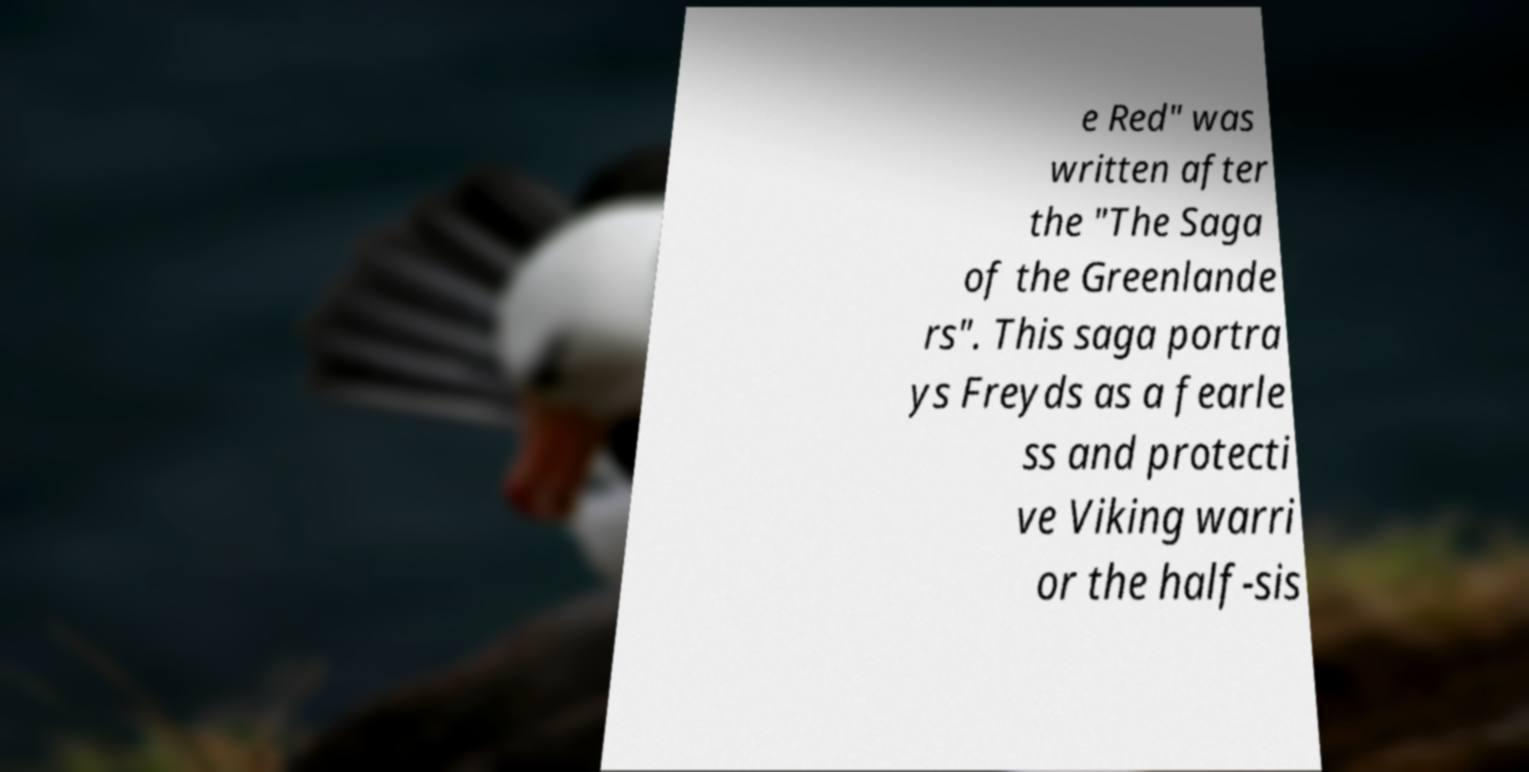Could you extract and type out the text from this image? e Red" was written after the "The Saga of the Greenlande rs". This saga portra ys Freyds as a fearle ss and protecti ve Viking warri or the half-sis 